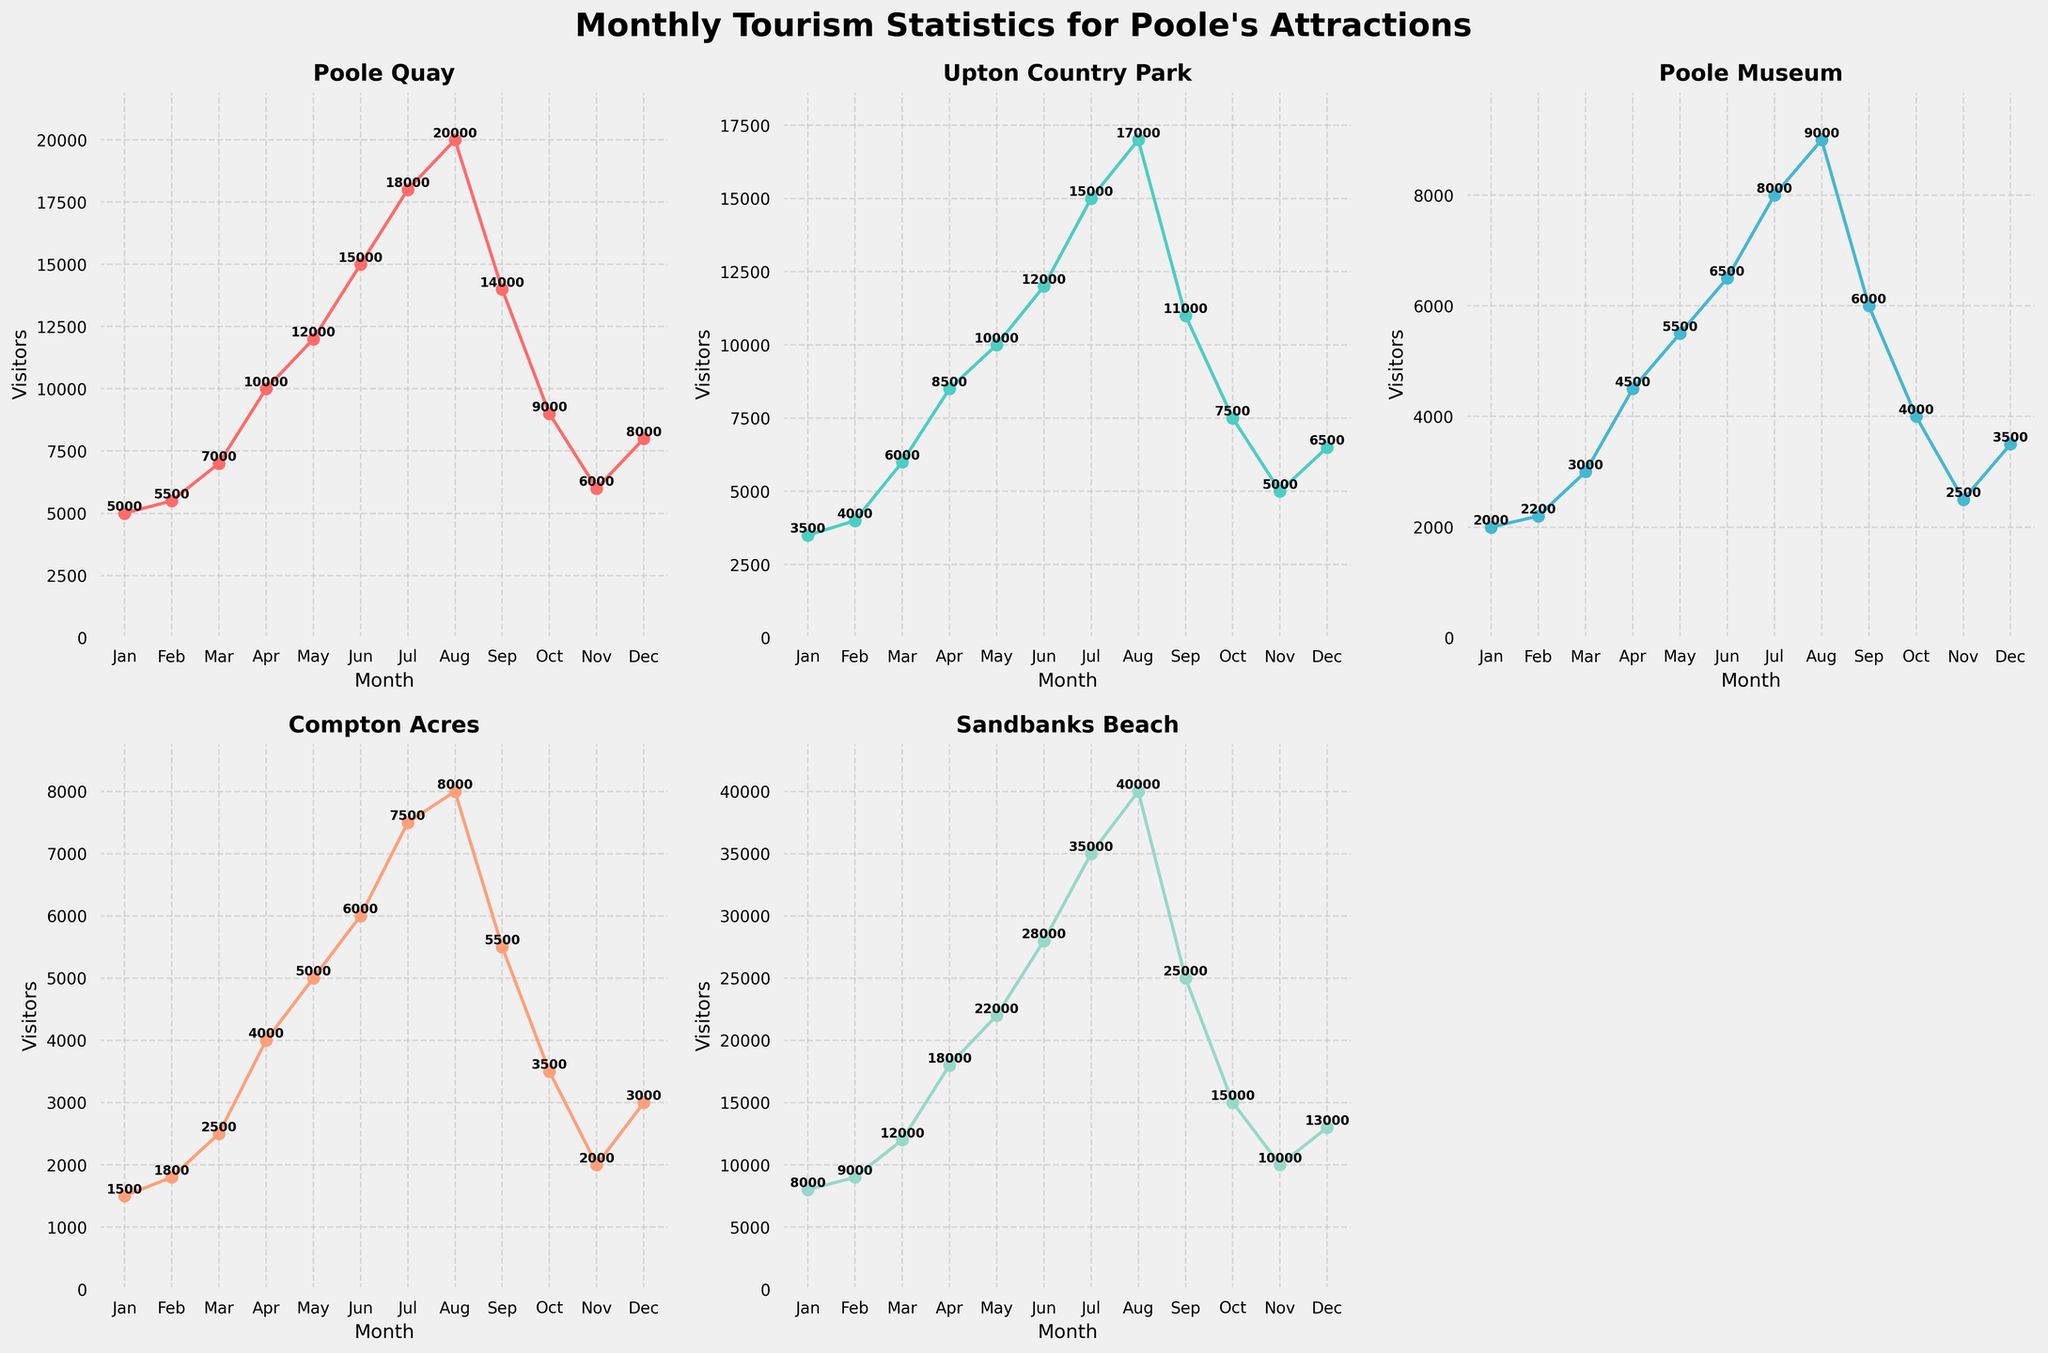What is the title of the figure? The title is located at the top of the figure, above the subplots.
Answer: Monthly Tourism Statistics for Poole's Attractions Which month had the highest number of visitors to Sandbanks Beach? By looking at the Sandbanks Beach subplot, the highest point on the plot corresponds to the month of August.
Answer: August How many attractions are displayed in the subplots? Each subplot represents one attraction, and there are 5 subplots corresponding to 5 attractions.
Answer: 5 What is the color used for the Poole Museum plot line? The color of the plot line for Poole Museum can be observed in its corresponding subplot.
Answer: #45B7D1 (assuming the plot was created with specified colors) Which attraction has the lowest visitor count in the month of January? Compare the visitor counts for all attractions in January by looking at the starting point of each plot line. The lowest value is for Compton Acres with 1500 visitors.
Answer: Compton Acres What is the average number of visitors to Upton Country Park from June to August? Sum the visitors for Upton Country Park from June (12000), July (15000), and August (17000) and divide by 3 to get the average: (12000 + 15000 + 17000) / 3 = 14666.67
Answer: 14666.67 Between which months does Poole Quay see the largest increase in visitors? By observing the plot for Poole Quay, the largest jump in visitors is between June and July (15000 to 18000).
Answer: June to July Which attraction experienced a decline in visitors from August to September? Check each subplot for a decrease from August to September. Compton Acres, Sandbanks Beach, Upton Country Park, and Poole Quay all show a decline in visitors during these months.
Answer: Compton Acres, Sandbanks Beach, Upton Country Park, Poole Quay For Compton Acres, is the number of visitors in June greater than in January and February combined? Compare June (6000) against January (1500) + February (1800): 6000 > (1500 + 1800) = 3300.
Answer: Yes Which month had the lowest number of visitors to the Poole Museum? In the subplot for Poole Museum, the lowest point on the plot is in January.
Answer: January 